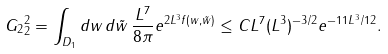Convert formula to latex. <formula><loc_0><loc_0><loc_500><loc_500>\| G _ { 2 } \| ^ { 2 } _ { 2 } = \int _ { D _ { 1 } } d w \, d \tilde { w } \, \frac { L ^ { 7 } } { 8 \pi } e ^ { 2 L ^ { 3 } f ( w , \tilde { w } ) } \leq C L ^ { 7 } ( L ^ { 3 } ) ^ { - 3 / 2 } e ^ { - 1 1 L ^ { 3 } / 1 2 } .</formula> 